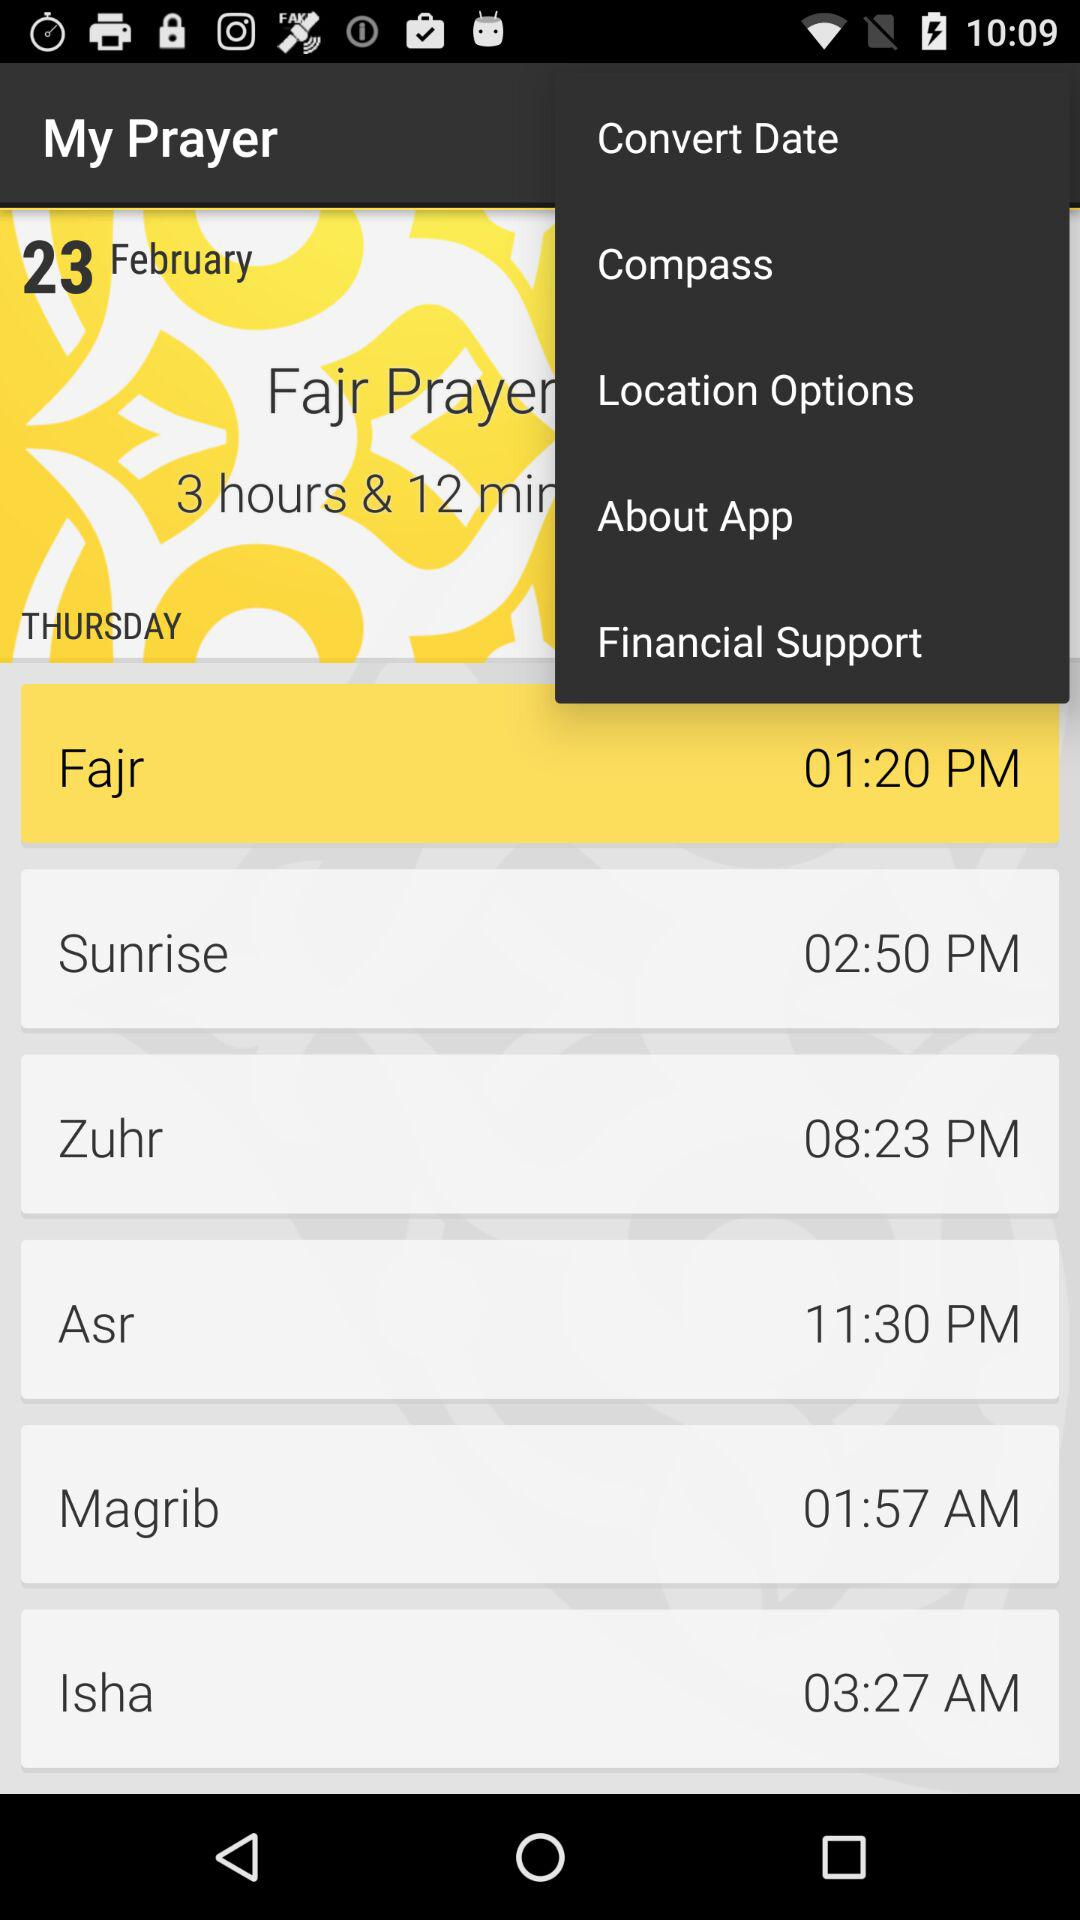What is the application name? The application name is "My Prayer". 